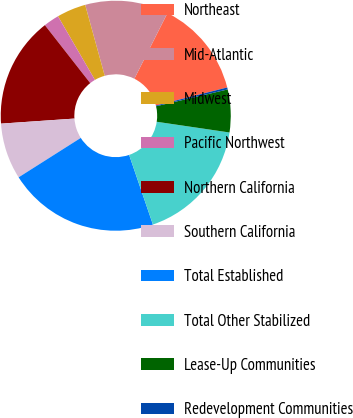Convert chart. <chart><loc_0><loc_0><loc_500><loc_500><pie_chart><fcel>Northeast<fcel>Mid-Atlantic<fcel>Midwest<fcel>Pacific Northwest<fcel>Northern California<fcel>Southern California<fcel>Total Established<fcel>Total Other Stabilized<fcel>Lease-Up Communities<fcel>Redevelopment Communities<nl><fcel>13.62%<fcel>11.71%<fcel>4.09%<fcel>2.19%<fcel>15.53%<fcel>7.9%<fcel>21.24%<fcel>17.43%<fcel>6.0%<fcel>0.28%<nl></chart> 